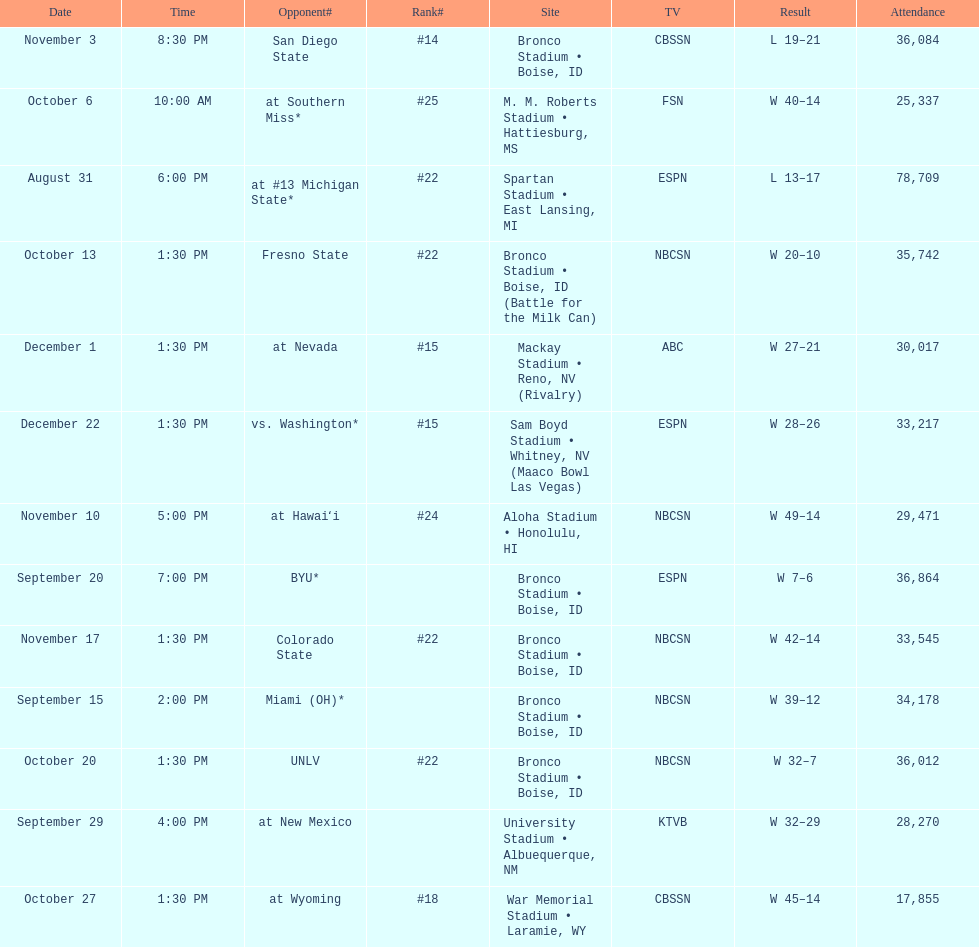Who were all of the opponents? At #13 michigan state*, miami (oh)*, byu*, at new mexico, at southern miss*, fresno state, unlv, at wyoming, san diego state, at hawaiʻi, colorado state, at nevada, vs. washington*. Who did they face on november 3rd? San Diego State. What rank were they on november 3rd? #14. 